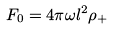Convert formula to latex. <formula><loc_0><loc_0><loc_500><loc_500>F _ { 0 } = 4 \pi \omega l ^ { 2 } \rho _ { + }</formula> 